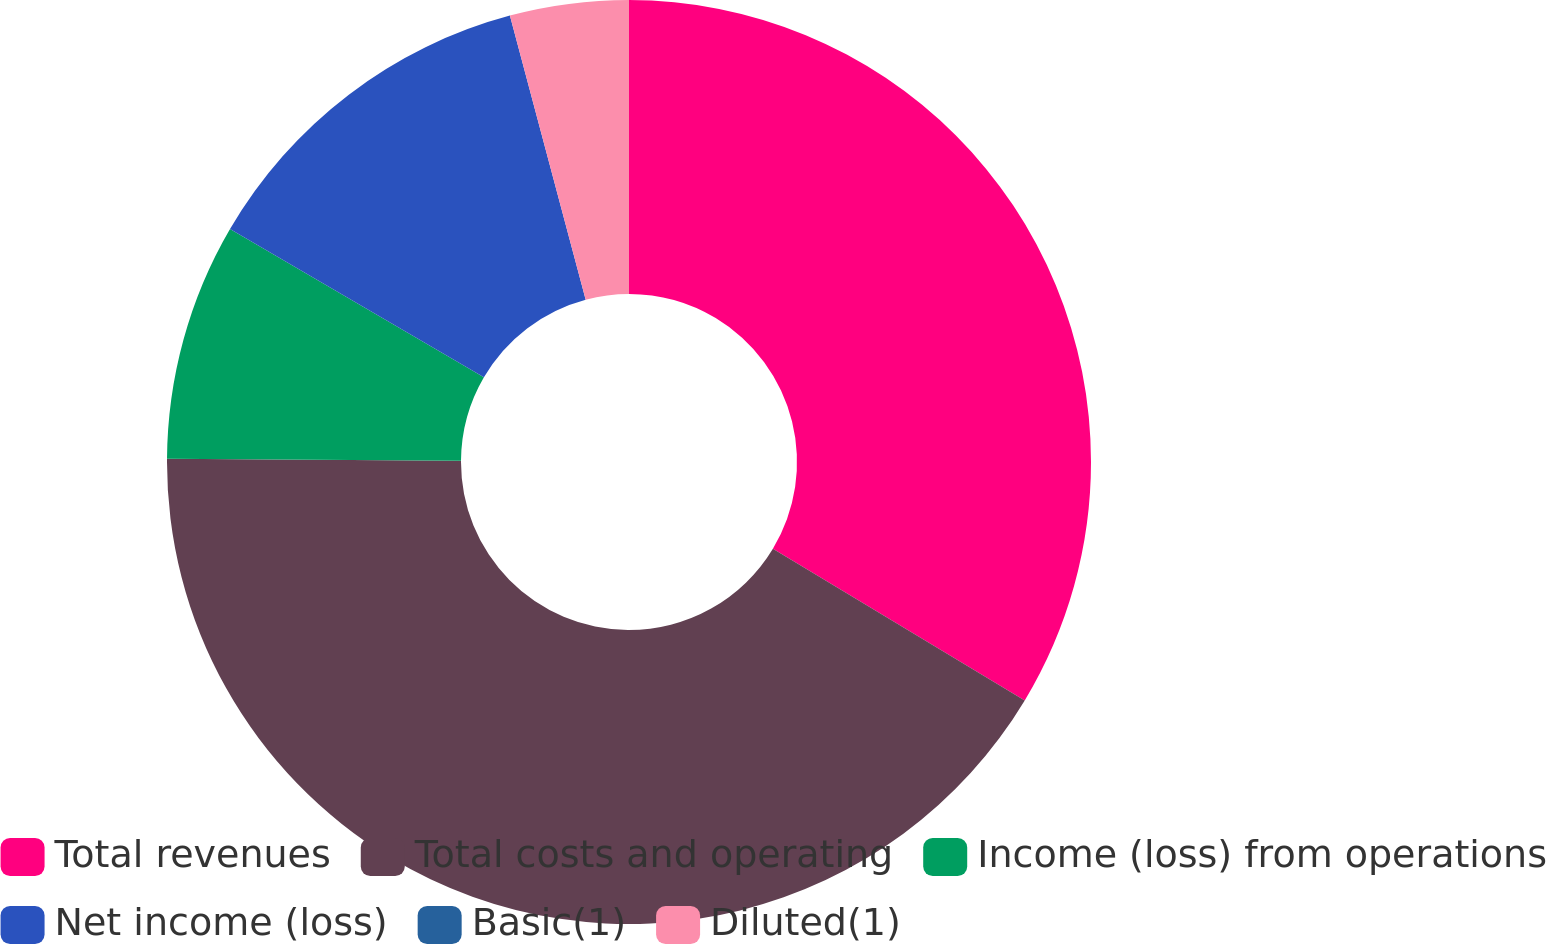<chart> <loc_0><loc_0><loc_500><loc_500><pie_chart><fcel>Total revenues<fcel>Total costs and operating<fcel>Income (loss) from operations<fcel>Net income (loss)<fcel>Basic(1)<fcel>Diluted(1)<nl><fcel>33.63%<fcel>41.48%<fcel>8.3%<fcel>12.44%<fcel>0.0%<fcel>4.15%<nl></chart> 